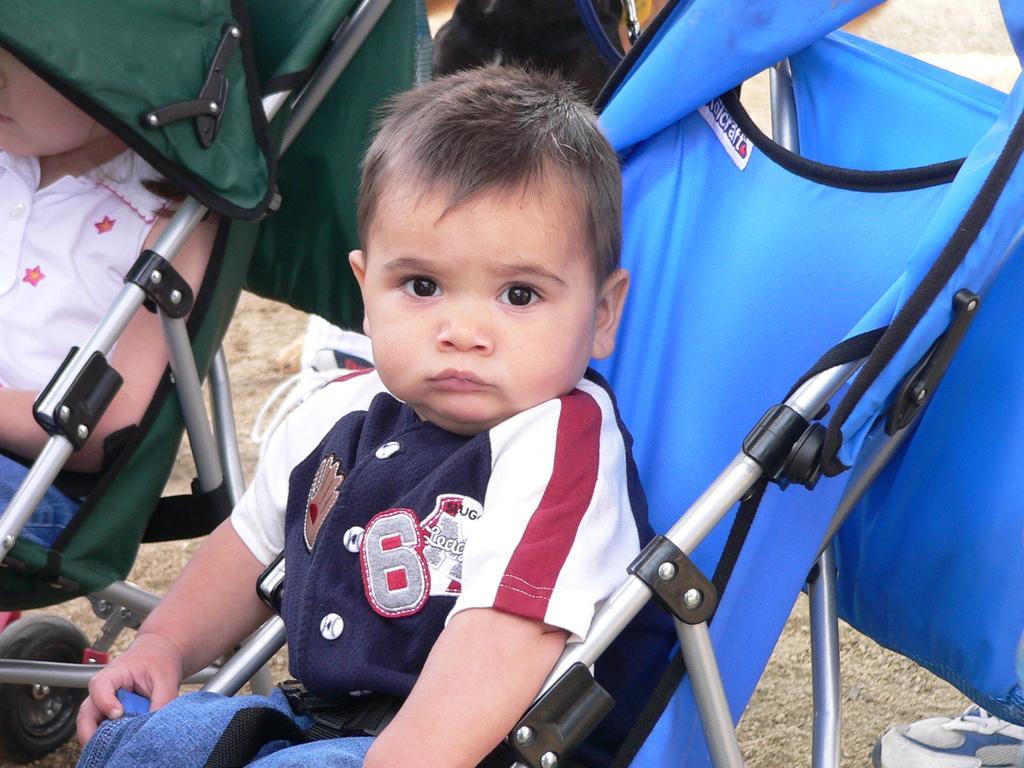In one or two sentences, can you explain what this image depicts? In this image I can see there are two babies sitting on chairs and I can see shoe visible at the bottom. 